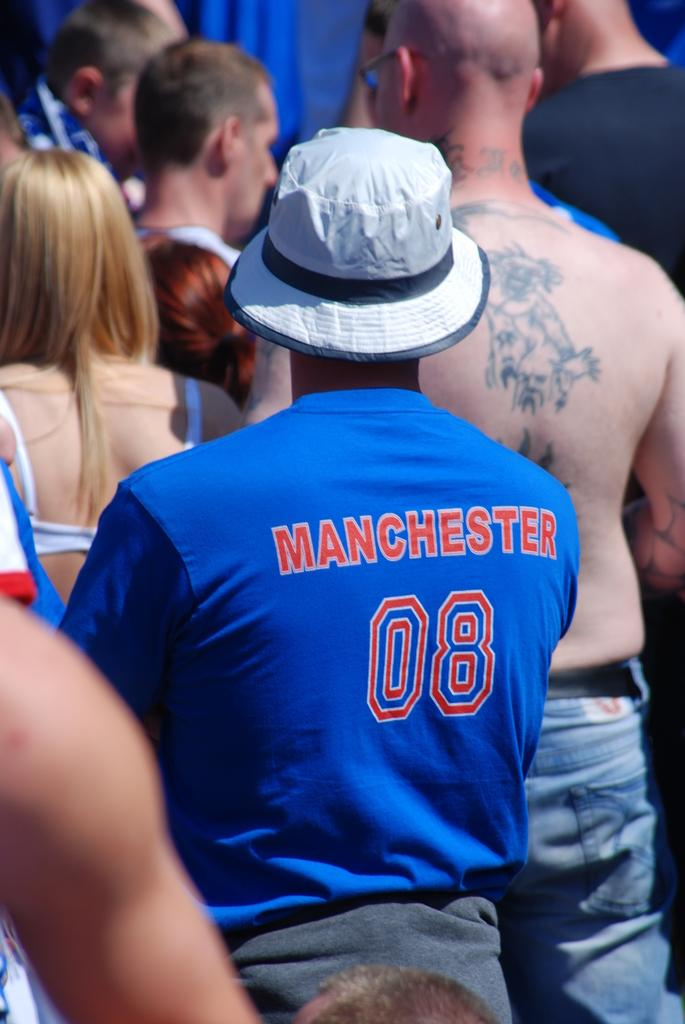<image>
Give a short and clear explanation of the subsequent image. the backs of some people standing, the shirt says MANCHESTER 08 and another man's bare back has tattoos on it. 